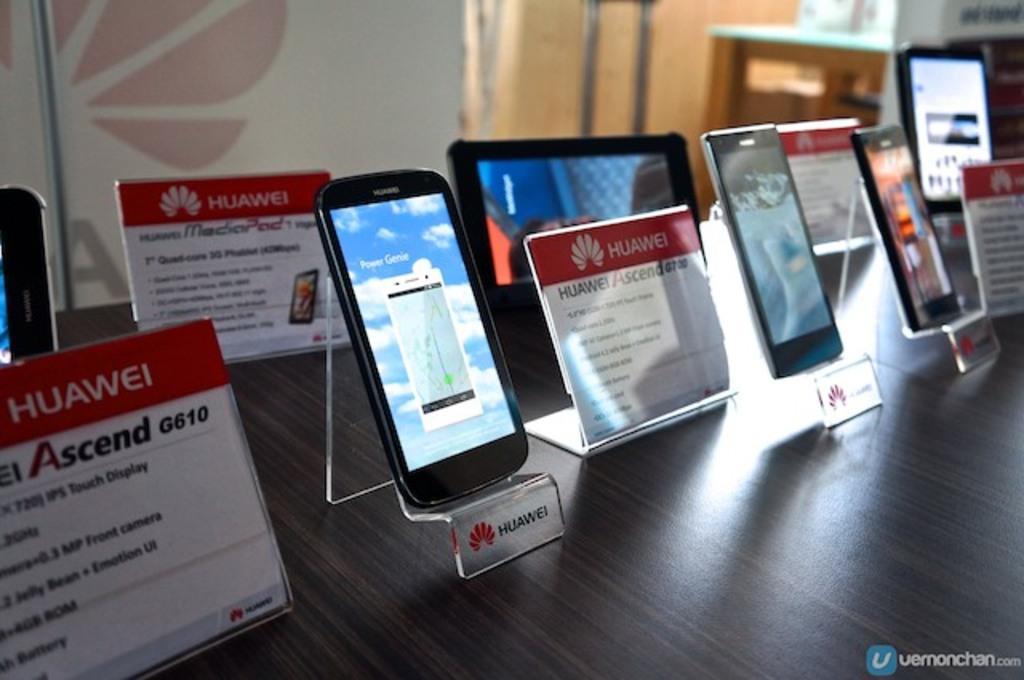<image>
Render a clear and concise summary of the photo. A display of Huawei smart devices with signs telling about their  aspects. 